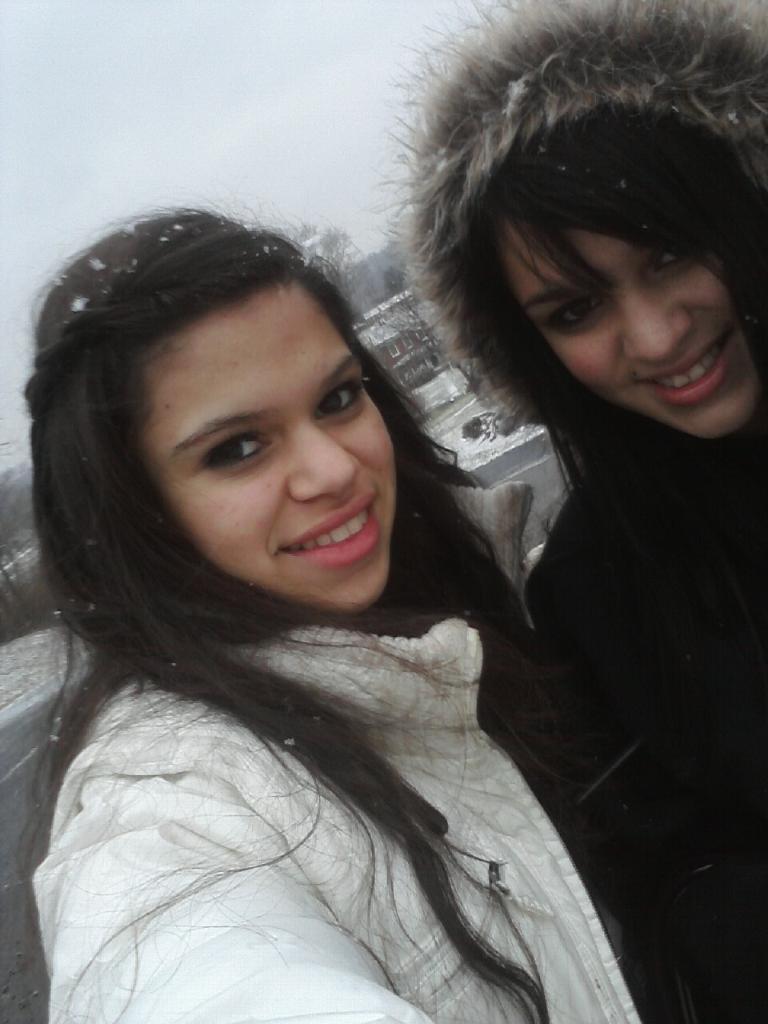Can you describe this image briefly? In the image two women were taking a selfie, the climate is very cool, behind the women there is a house and in the background there is a sky. 